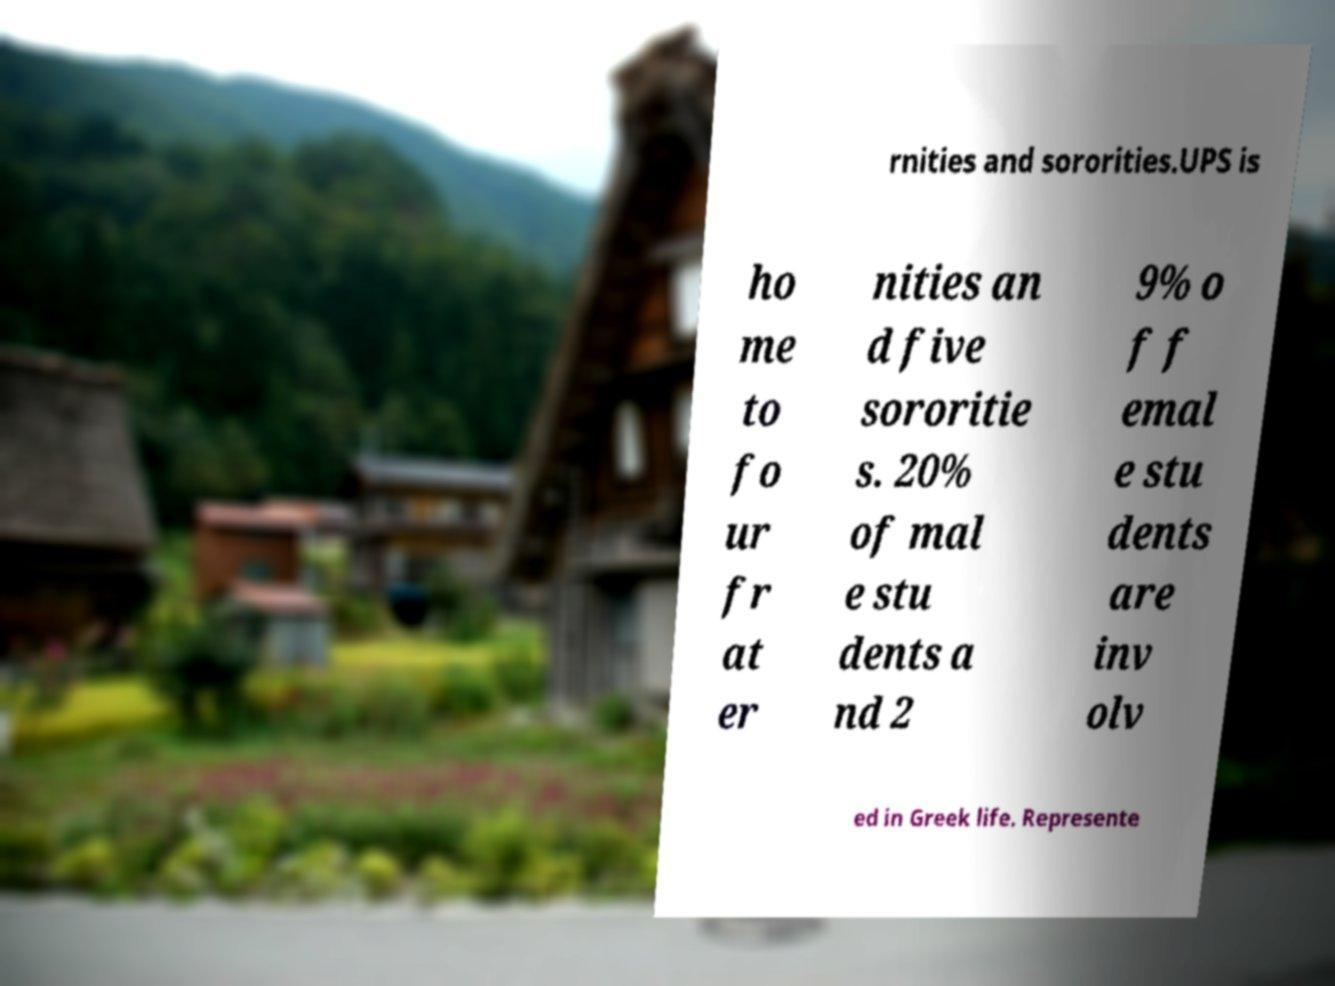What messages or text are displayed in this image? I need them in a readable, typed format. rnities and sororities.UPS is ho me to fo ur fr at er nities an d five sororitie s. 20% of mal e stu dents a nd 2 9% o f f emal e stu dents are inv olv ed in Greek life. Represente 